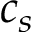Convert formula to latex. <formula><loc_0><loc_0><loc_500><loc_500>c _ { s }</formula> 